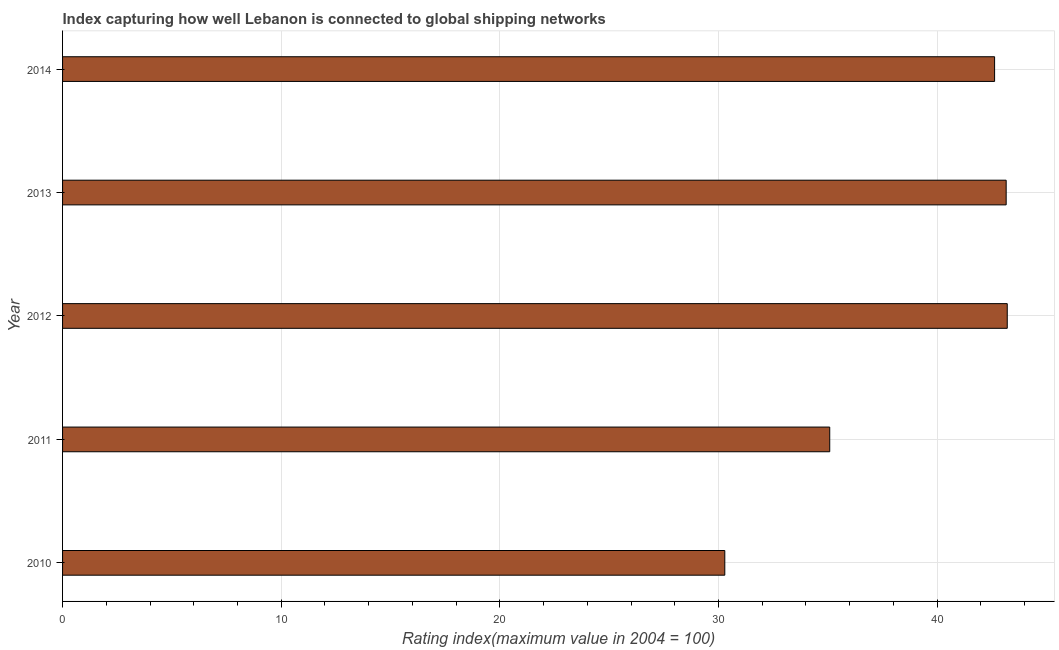Does the graph contain any zero values?
Offer a very short reply. No. What is the title of the graph?
Provide a succinct answer. Index capturing how well Lebanon is connected to global shipping networks. What is the label or title of the X-axis?
Give a very brief answer. Rating index(maximum value in 2004 = 100). What is the liner shipping connectivity index in 2014?
Provide a succinct answer. 42.63. Across all years, what is the maximum liner shipping connectivity index?
Ensure brevity in your answer.  43.21. Across all years, what is the minimum liner shipping connectivity index?
Give a very brief answer. 30.29. In which year was the liner shipping connectivity index maximum?
Offer a very short reply. 2012. What is the sum of the liner shipping connectivity index?
Make the answer very short. 194.38. What is the average liner shipping connectivity index per year?
Your answer should be very brief. 38.88. What is the median liner shipping connectivity index?
Your response must be concise. 42.63. What is the ratio of the liner shipping connectivity index in 2011 to that in 2014?
Make the answer very short. 0.82. Is the difference between the liner shipping connectivity index in 2012 and 2014 greater than the difference between any two years?
Your answer should be compact. No. What is the difference between the highest and the lowest liner shipping connectivity index?
Your answer should be very brief. 12.92. How many bars are there?
Your response must be concise. 5. Are all the bars in the graph horizontal?
Keep it short and to the point. Yes. Are the values on the major ticks of X-axis written in scientific E-notation?
Your response must be concise. No. What is the Rating index(maximum value in 2004 = 100) of 2010?
Your answer should be very brief. 30.29. What is the Rating index(maximum value in 2004 = 100) of 2011?
Keep it short and to the point. 35.09. What is the Rating index(maximum value in 2004 = 100) of 2012?
Your response must be concise. 43.21. What is the Rating index(maximum value in 2004 = 100) of 2013?
Provide a succinct answer. 43.16. What is the Rating index(maximum value in 2004 = 100) in 2014?
Your response must be concise. 42.63. What is the difference between the Rating index(maximum value in 2004 = 100) in 2010 and 2012?
Your answer should be compact. -12.92. What is the difference between the Rating index(maximum value in 2004 = 100) in 2010 and 2013?
Keep it short and to the point. -12.87. What is the difference between the Rating index(maximum value in 2004 = 100) in 2010 and 2014?
Your answer should be very brief. -12.34. What is the difference between the Rating index(maximum value in 2004 = 100) in 2011 and 2012?
Keep it short and to the point. -8.12. What is the difference between the Rating index(maximum value in 2004 = 100) in 2011 and 2013?
Give a very brief answer. -8.07. What is the difference between the Rating index(maximum value in 2004 = 100) in 2011 and 2014?
Offer a terse response. -7.54. What is the difference between the Rating index(maximum value in 2004 = 100) in 2012 and 2013?
Keep it short and to the point. 0.05. What is the difference between the Rating index(maximum value in 2004 = 100) in 2012 and 2014?
Your answer should be very brief. 0.58. What is the difference between the Rating index(maximum value in 2004 = 100) in 2013 and 2014?
Keep it short and to the point. 0.53. What is the ratio of the Rating index(maximum value in 2004 = 100) in 2010 to that in 2011?
Offer a terse response. 0.86. What is the ratio of the Rating index(maximum value in 2004 = 100) in 2010 to that in 2012?
Your answer should be very brief. 0.7. What is the ratio of the Rating index(maximum value in 2004 = 100) in 2010 to that in 2013?
Your answer should be compact. 0.7. What is the ratio of the Rating index(maximum value in 2004 = 100) in 2010 to that in 2014?
Offer a terse response. 0.71. What is the ratio of the Rating index(maximum value in 2004 = 100) in 2011 to that in 2012?
Keep it short and to the point. 0.81. What is the ratio of the Rating index(maximum value in 2004 = 100) in 2011 to that in 2013?
Ensure brevity in your answer.  0.81. What is the ratio of the Rating index(maximum value in 2004 = 100) in 2011 to that in 2014?
Provide a succinct answer. 0.82. What is the ratio of the Rating index(maximum value in 2004 = 100) in 2012 to that in 2013?
Your answer should be very brief. 1. What is the ratio of the Rating index(maximum value in 2004 = 100) in 2012 to that in 2014?
Your response must be concise. 1.01. What is the ratio of the Rating index(maximum value in 2004 = 100) in 2013 to that in 2014?
Your answer should be compact. 1.01. 